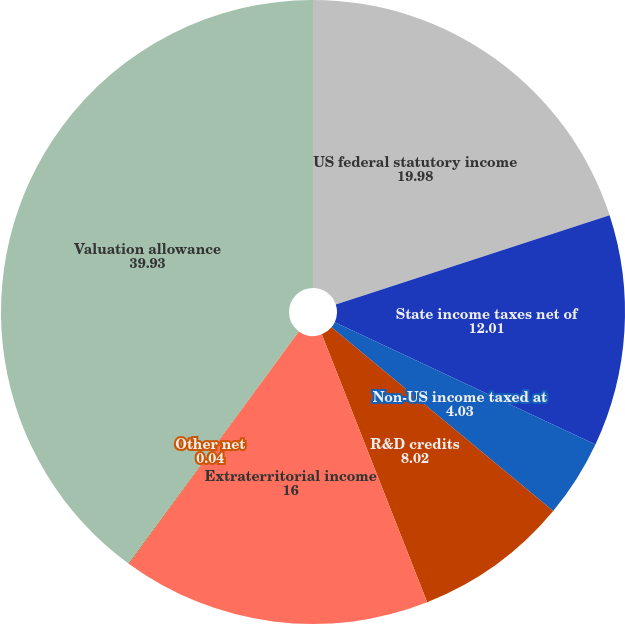Convert chart. <chart><loc_0><loc_0><loc_500><loc_500><pie_chart><fcel>US federal statutory income<fcel>State income taxes net of<fcel>Non-US income taxed at<fcel>R&D credits<fcel>Extraterritorial income<fcel>Other net<fcel>Valuation allowance<nl><fcel>19.98%<fcel>12.01%<fcel>4.03%<fcel>8.02%<fcel>16.0%<fcel>0.04%<fcel>39.93%<nl></chart> 